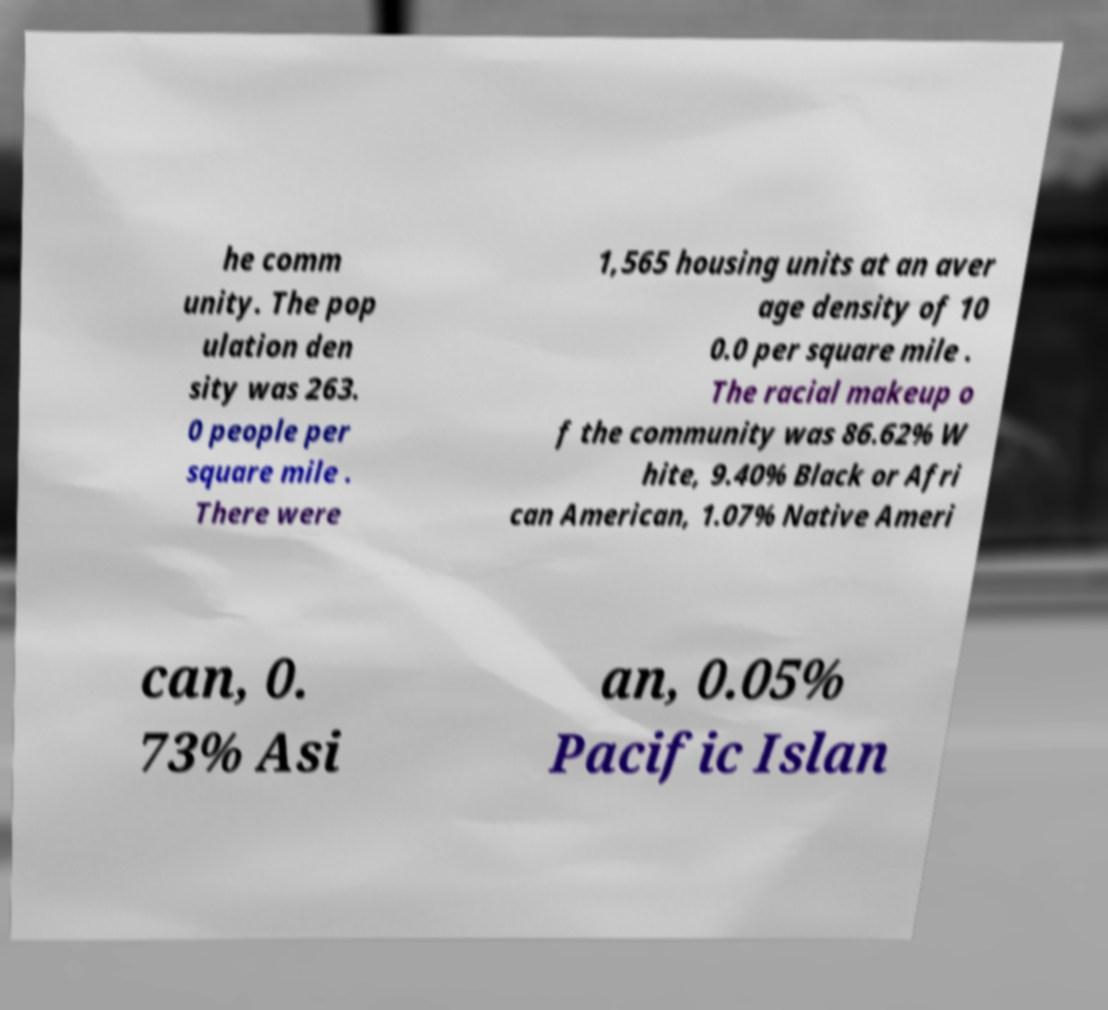Can you accurately transcribe the text from the provided image for me? he comm unity. The pop ulation den sity was 263. 0 people per square mile . There were 1,565 housing units at an aver age density of 10 0.0 per square mile . The racial makeup o f the community was 86.62% W hite, 9.40% Black or Afri can American, 1.07% Native Ameri can, 0. 73% Asi an, 0.05% Pacific Islan 